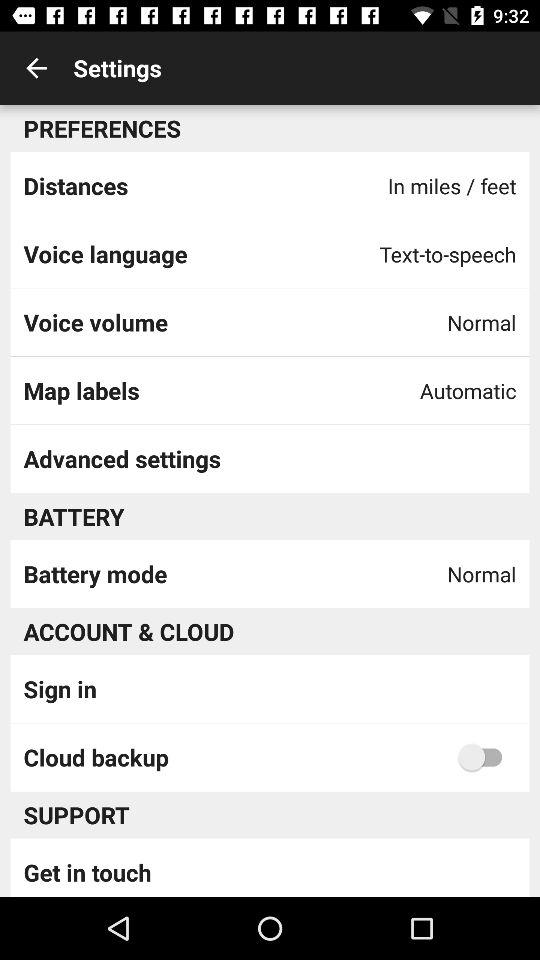What is the setting for "Distances"? The setting for "Distances" is miles or feet. 